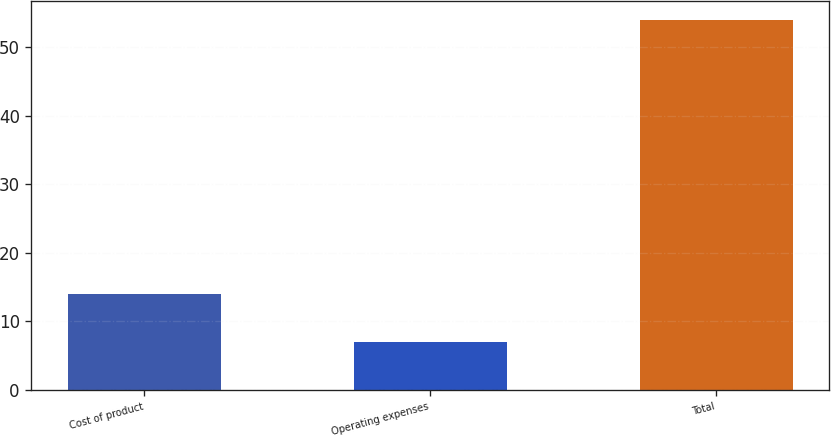Convert chart. <chart><loc_0><loc_0><loc_500><loc_500><bar_chart><fcel>Cost of product<fcel>Operating expenses<fcel>Total<nl><fcel>14<fcel>7<fcel>54<nl></chart> 